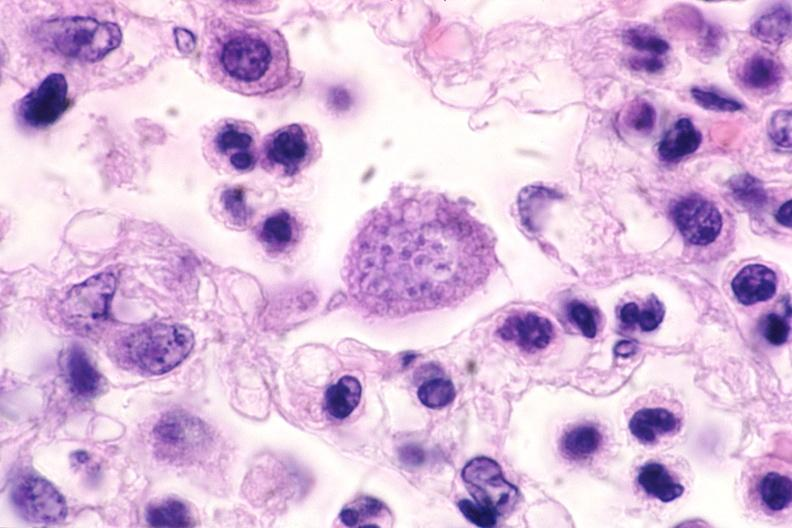s multiple myeloma present?
Answer the question using a single word or phrase. No 